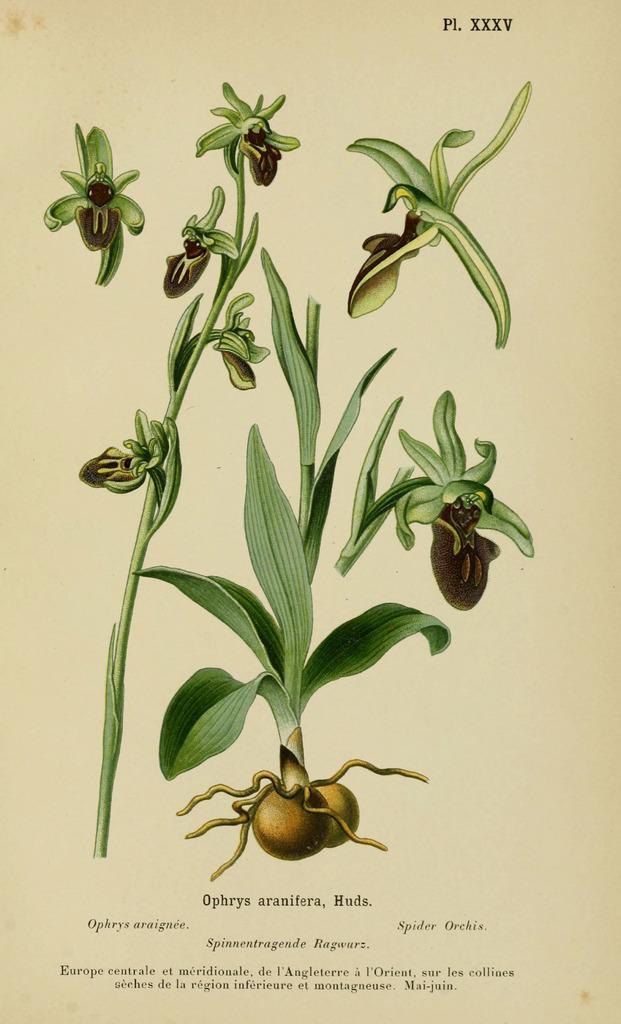In one or two sentences, can you explain what this image depicts? In this image I can see the depiction of few plants which are green in color and its roots which are brown in color. I can see the cream colored background and few words written on it. 